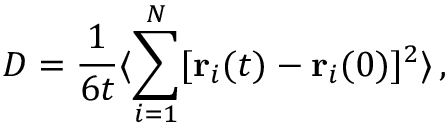<formula> <loc_0><loc_0><loc_500><loc_500>D = \frac { 1 } { 6 t } \langle \sum _ { i = 1 } ^ { N } [ r _ { i } ( t ) - r _ { i } ( 0 ) ] ^ { 2 } \rangle \, ,</formula> 